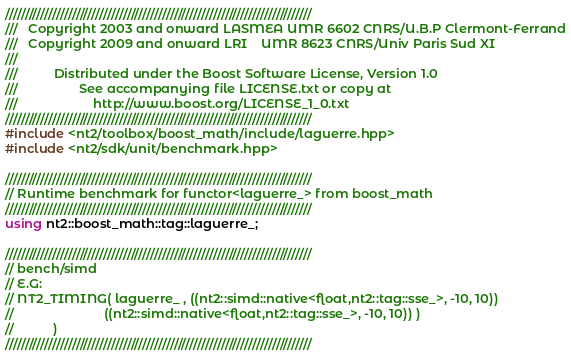Convert code to text. <code><loc_0><loc_0><loc_500><loc_500><_C++_>//////////////////////////////////////////////////////////////////////////////
///   Copyright 2003 and onward LASMEA UMR 6602 CNRS/U.B.P Clermont-Ferrand
///   Copyright 2009 and onward LRI    UMR 8623 CNRS/Univ Paris Sud XI
///
///          Distributed under the Boost Software License, Version 1.0
///                 See accompanying file LICENSE.txt or copy at
///                     http://www.boost.org/LICENSE_1_0.txt
//////////////////////////////////////////////////////////////////////////////
#include <nt2/toolbox/boost_math/include/laguerre.hpp>
#include <nt2/sdk/unit/benchmark.hpp>

//////////////////////////////////////////////////////////////////////////////
// Runtime benchmark for functor<laguerre_> from boost_math
//////////////////////////////////////////////////////////////////////////////
using nt2::boost_math::tag::laguerre_;

//////////////////////////////////////////////////////////////////////////////
// bench/simd
// E.G:
// NT2_TIMING( laguerre_ , ((nt2::simd::native<float,nt2::tag::sse_>, -10, 10))
//                         ((nt2::simd::native<float,nt2::tag::sse_>, -10, 10)) ) 
//           )
//////////////////////////////////////////////////////////////////////////////
</code> 